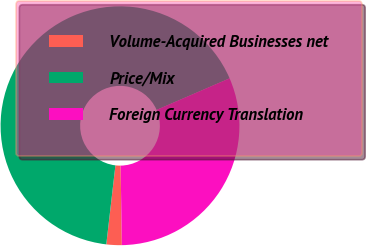Convert chart to OTSL. <chart><loc_0><loc_0><loc_500><loc_500><pie_chart><fcel>Volume-Acquired Businesses net<fcel>Price/Mix<fcel>Foreign Currency Translation<nl><fcel>2.08%<fcel>66.67%<fcel>31.25%<nl></chart> 